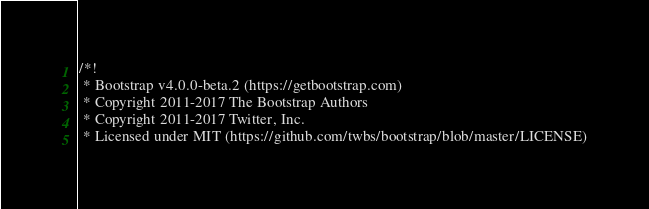<code> <loc_0><loc_0><loc_500><loc_500><_CSS_>/*!
 * Bootstrap v4.0.0-beta.2 (https://getbootstrap.com)
 * Copyright 2011-2017 The Bootstrap Authors
 * Copyright 2011-2017 Twitter, Inc.
 * Licensed under MIT (https://github.com/twbs/bootstrap/blob/master/LICENSE)</code> 